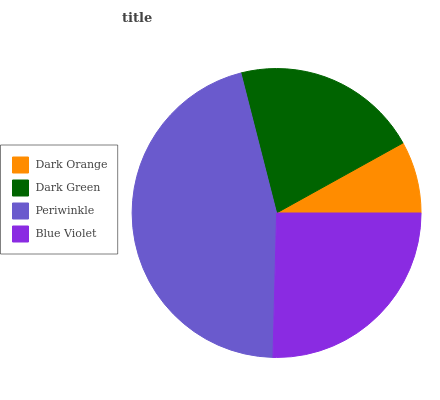Is Dark Orange the minimum?
Answer yes or no. Yes. Is Periwinkle the maximum?
Answer yes or no. Yes. Is Dark Green the minimum?
Answer yes or no. No. Is Dark Green the maximum?
Answer yes or no. No. Is Dark Green greater than Dark Orange?
Answer yes or no. Yes. Is Dark Orange less than Dark Green?
Answer yes or no. Yes. Is Dark Orange greater than Dark Green?
Answer yes or no. No. Is Dark Green less than Dark Orange?
Answer yes or no. No. Is Blue Violet the high median?
Answer yes or no. Yes. Is Dark Green the low median?
Answer yes or no. Yes. Is Dark Orange the high median?
Answer yes or no. No. Is Dark Orange the low median?
Answer yes or no. No. 